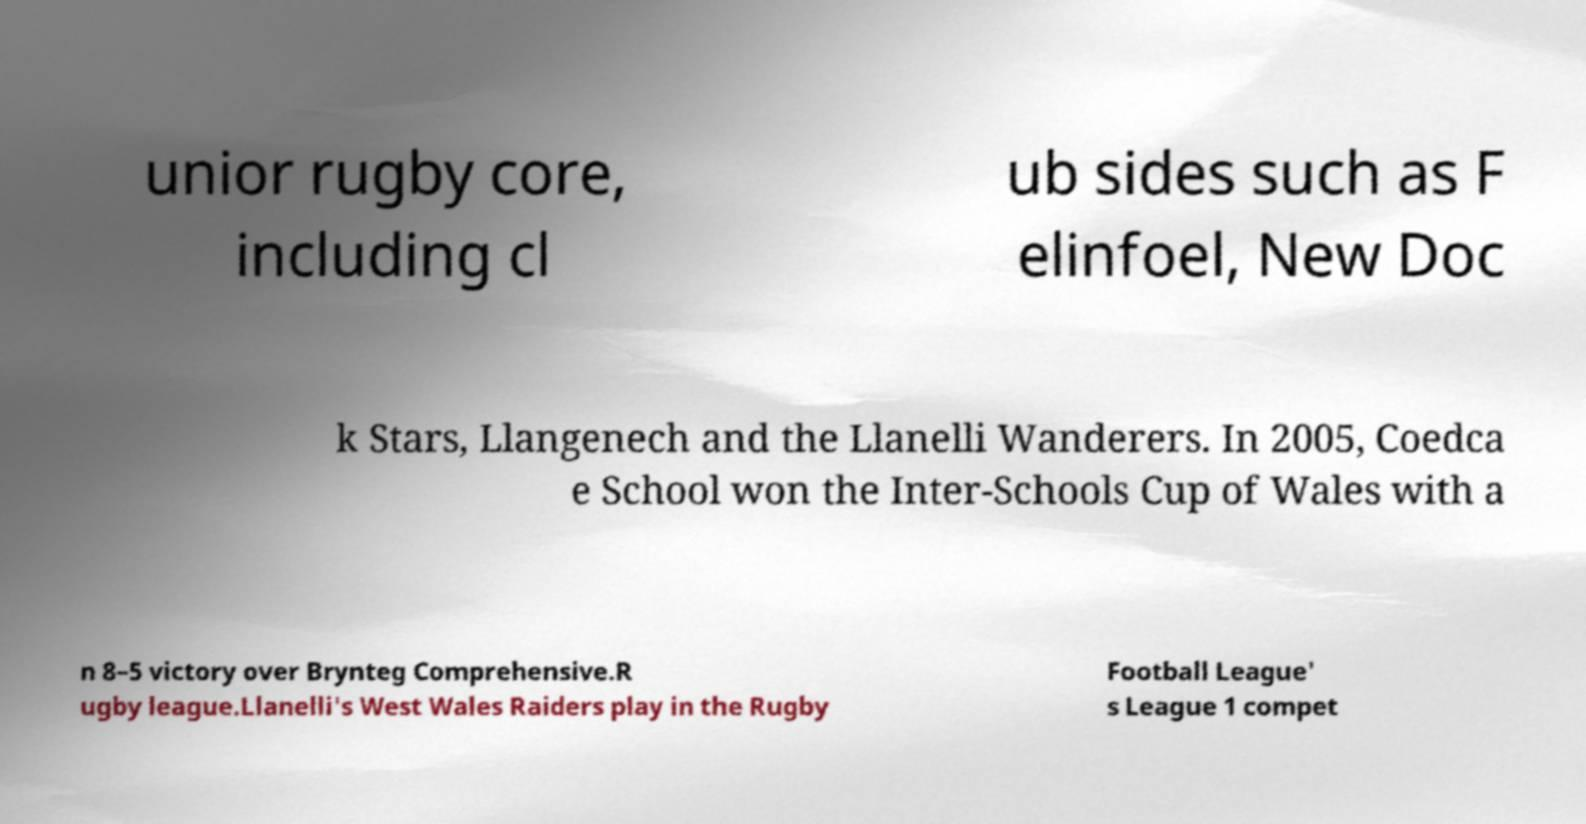Please identify and transcribe the text found in this image. unior rugby core, including cl ub sides such as F elinfoel, New Doc k Stars, Llangenech and the Llanelli Wanderers. In 2005, Coedca e School won the Inter-Schools Cup of Wales with a n 8–5 victory over Brynteg Comprehensive.R ugby league.Llanelli's West Wales Raiders play in the Rugby Football League' s League 1 compet 